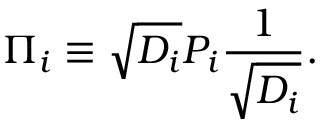Convert formula to latex. <formula><loc_0><loc_0><loc_500><loc_500>\Pi _ { i } \equiv \sqrt { D _ { i } } P _ { i } { \frac { 1 } { \sqrt { D _ { i } } } } .</formula> 